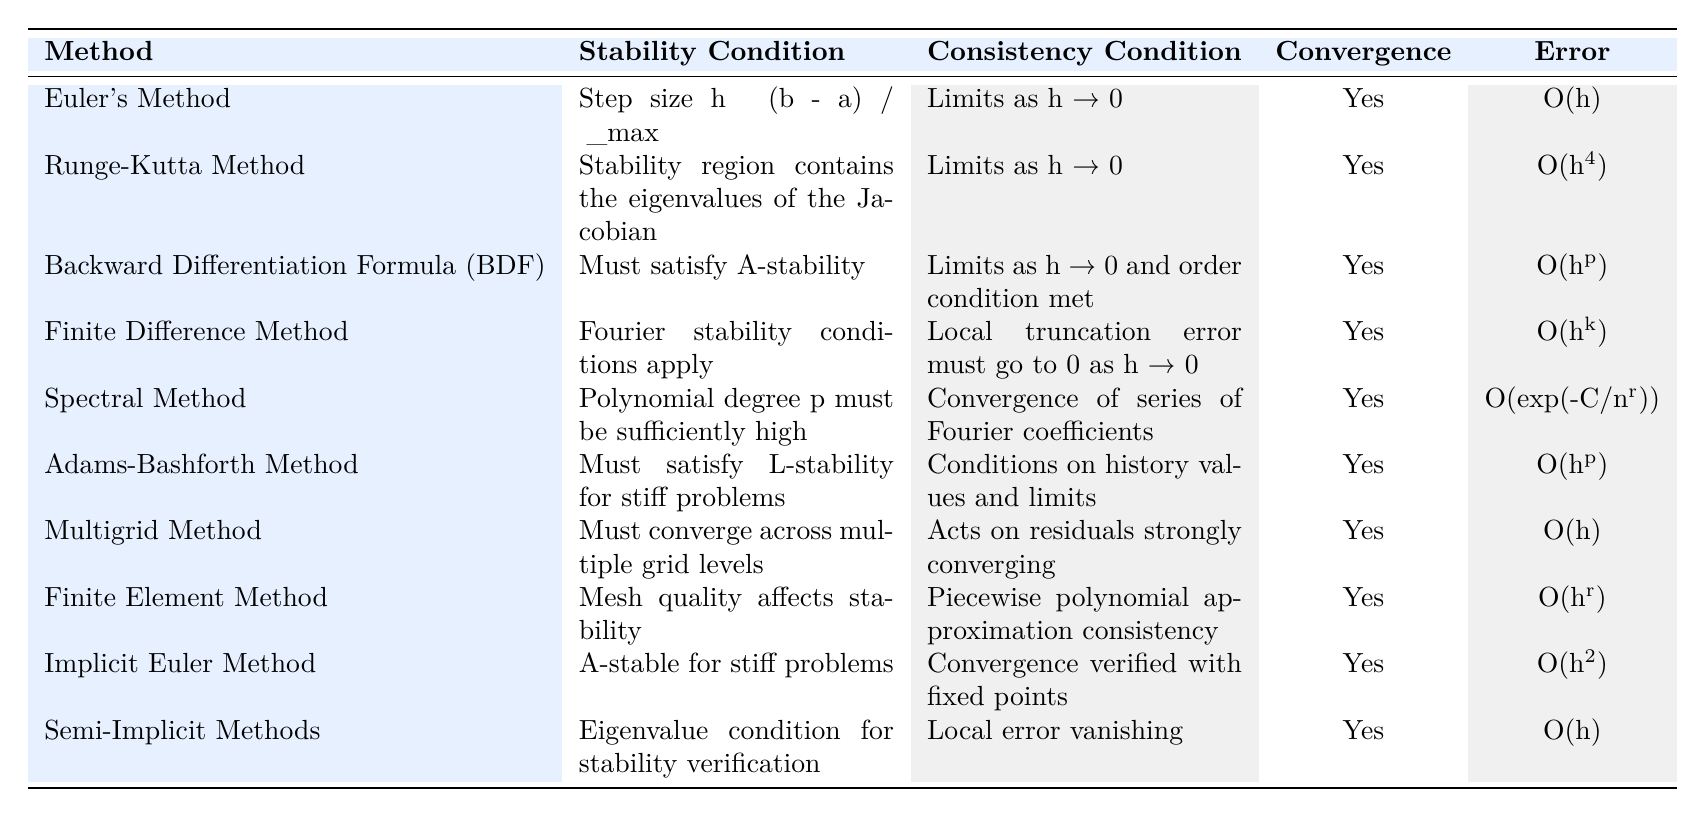What are the stability conditions for Euler's Method? From the table, the stability condition for Euler's Method is listed clearly: "Step size h ≤ (b - a) / λ_max". This directly states the requirement for the stability of the method.
Answer: Step size h ≤ (b - a) / λ_max What is the error rate for the Runge-Kutta Method? The table indicates that the error rate for the Runge-Kutta Method is "O(h^4)", which means the error decreases rapidly as the step size decreases.
Answer: O(h^4) Does the Finite Difference Method have a consistency condition? Yes, according to the table, the Finite Difference Method requires "Local truncation error must go to 0 as h → 0" as its consistency condition. This explains the behavior of the method as the step size h approaches 0.
Answer: Yes Which methods have an "O(h)" error rate? By examining the table, we can identify that the methods with an error rate of "O(h)" are Euler's Method, Multigrid Method, and Semi-Implicit Methods. These are the only methods listed with this specific error characterization.
Answer: Euler's Method, Multigrid Method, Semi-Implicit Methods Is the Spectral Method consistent? Yes, the Spectral Method is consistent as per the table, which states that "Convergence of series of Fourier coefficients" is its consistency condition. This suggests that the consistency of the method relies on the behavior of the Fourier series.
Answer: Yes What is the highest error rate among the methods listed? Upon reviewing the error rates in the table, the highest error rate is for the Runge-Kutta Method, which has an error rate of "O(h^4)". This indicates it has a lower rate of error compared to other methods.
Answer: O(h^4) Which methods require limits as h approaches 0 for their consistency condition? The methods that require limits as h approaches 0 for their consistency condition are Euler's Method, Runge-Kutta Method, Backward Differentiation Formula, Finite Difference Method, Implicit Euler Method, and Semi-Implicit Methods. These methods share this common consistency requirement.
Answer: Euler's Method, Runge-Kutta Method, Backward Differentiation Formula, Finite Difference Method, Implicit Euler Method, Semi-Implicit Methods How many methods satisfy the condition of A-stability? The table indicates that two methods satisfy A-stability: Backward Differentiation Formula (BDF) and Implicit Euler Method. Hence, there are two methods that fit this criterion.
Answer: 2 What is the convergence status of the Adams-Bashforth Method? According to the table, the Adams-Bashforth Method has a convergence status listed as "Yes", meaning it meets the necessary conditions to be considered convergent.
Answer: Yes 